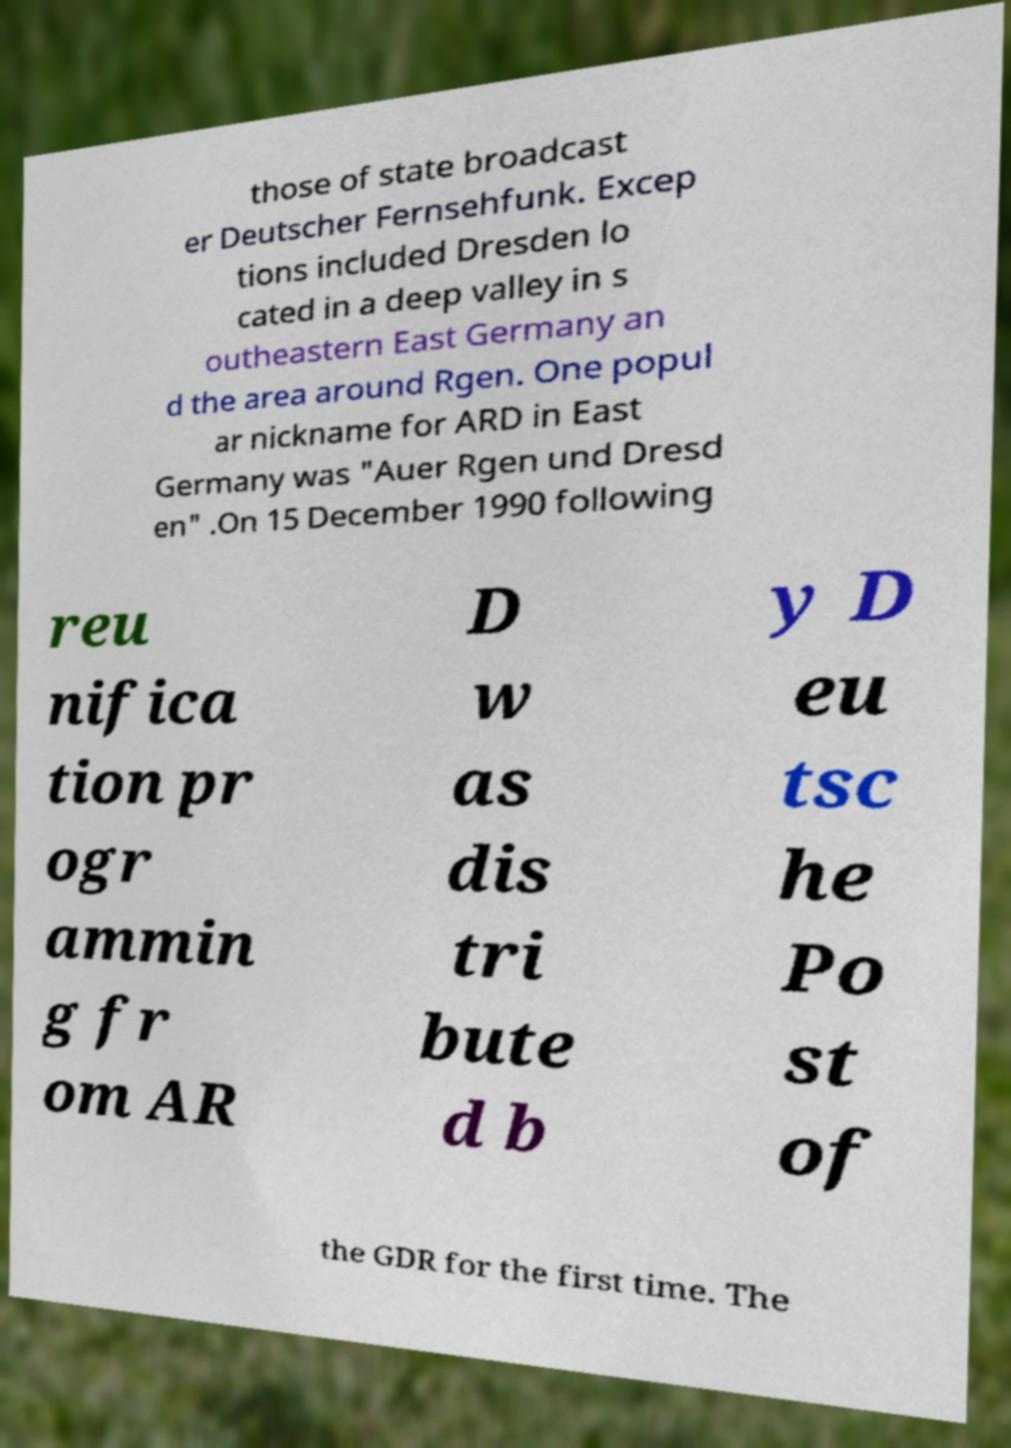Can you read and provide the text displayed in the image?This photo seems to have some interesting text. Can you extract and type it out for me? those of state broadcast er Deutscher Fernsehfunk. Excep tions included Dresden lo cated in a deep valley in s outheastern East Germany an d the area around Rgen. One popul ar nickname for ARD in East Germany was "Auer Rgen und Dresd en" .On 15 December 1990 following reu nifica tion pr ogr ammin g fr om AR D w as dis tri bute d b y D eu tsc he Po st of the GDR for the first time. The 